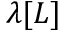Convert formula to latex. <formula><loc_0><loc_0><loc_500><loc_500>\lambda [ L ]</formula> 